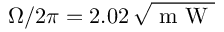<formula> <loc_0><loc_0><loc_500><loc_500>\Omega / 2 \pi = 2 . 0 2 \, \sqrt { m W }</formula> 